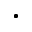Convert formula to latex. <formula><loc_0><loc_0><loc_500><loc_500>\bullet -</formula> 